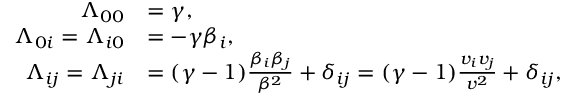Convert formula to latex. <formula><loc_0><loc_0><loc_500><loc_500>{ \begin{array} { r l } { \Lambda _ { 0 0 } } & { = \gamma , } \\ { \Lambda _ { 0 i } = \Lambda _ { i 0 } } & { = - \gamma \beta _ { i } , } \\ { \Lambda _ { i j } = \Lambda _ { j i } } & { = ( \gamma - 1 ) { \frac { \beta _ { i } \beta _ { j } } { \beta ^ { 2 } } } + \delta _ { i j } = ( \gamma - 1 ) { \frac { v _ { i } v _ { j } } { v ^ { 2 } } } + \delta _ { i j } , } \end{array} }</formula> 